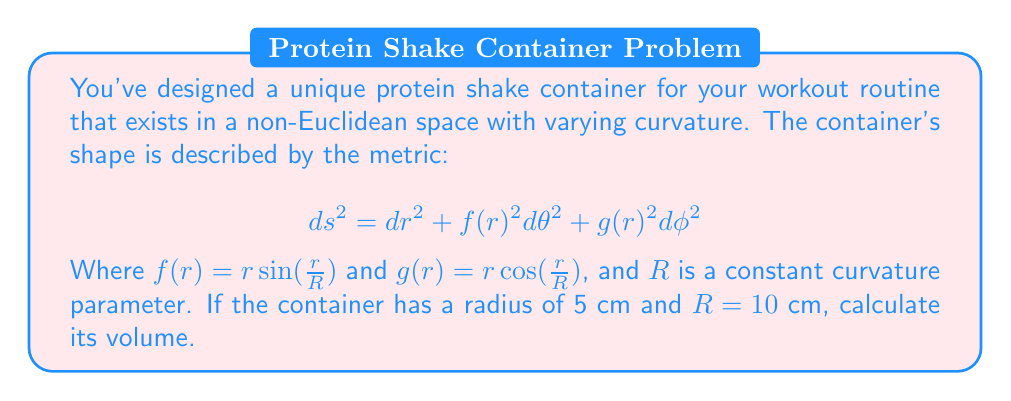Can you answer this question? To calculate the volume of this non-Euclidean container, we need to integrate the volume element over the entire space:

1) The volume element in this metric is given by:
   $$dV = \sqrt{\det(g_{ij})} dr d\theta d\phi = f(r)g(r) dr d\theta d\phi$$

2) Substituting the given functions:
   $$dV = r^2 \sin(\frac{r}{R})\cos(\frac{r}{R}) dr d\theta d\phi$$

3) The volume is then:
   $$V = \int_0^{2\pi} \int_0^{\pi} \int_0^5 r^2 \sin(\frac{r}{10})\cos(\frac{r}{10}) dr d\theta d\phi$$

4) Integrating over $\theta$ and $\phi$:
   $$V = 4\pi \int_0^5 r^2 \sin(\frac{r}{10})\cos(\frac{r}{10}) dr$$

5) This integral doesn't have a simple analytical solution, so we need to use numerical integration. Using a computer algebra system or numerical integration tool, we can evaluate this integral.

6) The result of this numerical integration is approximately 523.60 cm³.
Answer: 523.60 cm³ 